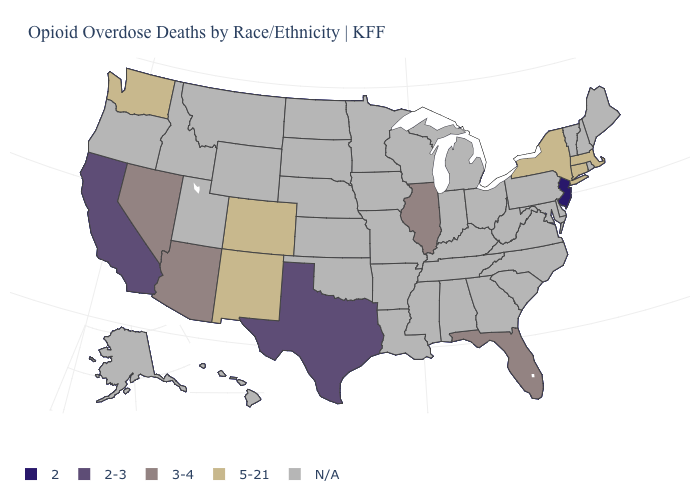What is the value of Pennsylvania?
Be succinct. N/A. Does the map have missing data?
Concise answer only. Yes. What is the value of Alaska?
Be succinct. N/A. Among the states that border Colorado , does Arizona have the highest value?
Short answer required. No. What is the value of Illinois?
Short answer required. 3-4. Name the states that have a value in the range 2-3?
Answer briefly. California, Texas. Which states have the highest value in the USA?
Short answer required. Colorado, Connecticut, Massachusetts, New Mexico, New York, Washington. Which states have the highest value in the USA?
Write a very short answer. Colorado, Connecticut, Massachusetts, New Mexico, New York, Washington. What is the highest value in the West ?
Concise answer only. 5-21. Does Washington have the lowest value in the USA?
Answer briefly. No. Is the legend a continuous bar?
Concise answer only. No. Which states have the lowest value in the West?
Give a very brief answer. California. Name the states that have a value in the range N/A?
Write a very short answer. Alabama, Alaska, Arkansas, Delaware, Georgia, Hawaii, Idaho, Indiana, Iowa, Kansas, Kentucky, Louisiana, Maine, Maryland, Michigan, Minnesota, Mississippi, Missouri, Montana, Nebraska, New Hampshire, North Carolina, North Dakota, Ohio, Oklahoma, Oregon, Pennsylvania, Rhode Island, South Carolina, South Dakota, Tennessee, Utah, Vermont, Virginia, West Virginia, Wisconsin, Wyoming. 